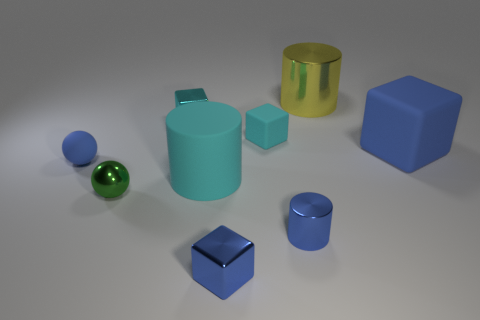Add 1 large cyan matte things. How many objects exist? 10 Subtract all spheres. How many objects are left? 7 Add 1 cyan cubes. How many cyan cubes are left? 3 Add 4 small metal cylinders. How many small metal cylinders exist? 5 Subtract 0 cyan balls. How many objects are left? 9 Subtract all big yellow things. Subtract all tiny cyan cubes. How many objects are left? 6 